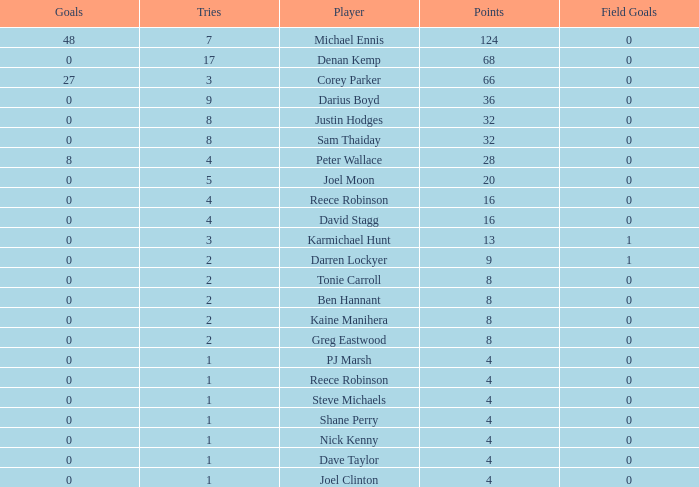What is the number of goals Dave Taylor, who has more than 1 tries, has? None. 